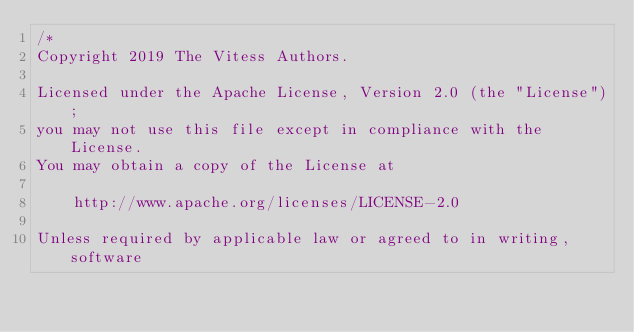<code> <loc_0><loc_0><loc_500><loc_500><_Go_>/*
Copyright 2019 The Vitess Authors.

Licensed under the Apache License, Version 2.0 (the "License");
you may not use this file except in compliance with the License.
You may obtain a copy of the License at

    http://www.apache.org/licenses/LICENSE-2.0

Unless required by applicable law or agreed to in writing, software</code> 